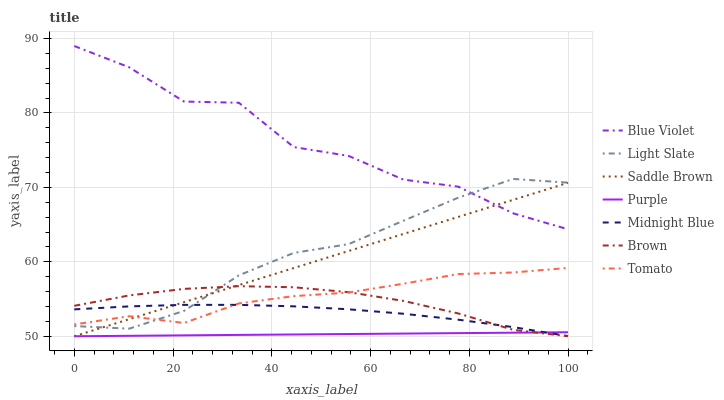Does Purple have the minimum area under the curve?
Answer yes or no. Yes. Does Blue Violet have the maximum area under the curve?
Answer yes or no. Yes. Does Brown have the minimum area under the curve?
Answer yes or no. No. Does Brown have the maximum area under the curve?
Answer yes or no. No. Is Purple the smoothest?
Answer yes or no. Yes. Is Blue Violet the roughest?
Answer yes or no. Yes. Is Brown the smoothest?
Answer yes or no. No. Is Brown the roughest?
Answer yes or no. No. Does Brown have the lowest value?
Answer yes or no. Yes. Does Midnight Blue have the lowest value?
Answer yes or no. No. Does Blue Violet have the highest value?
Answer yes or no. Yes. Does Brown have the highest value?
Answer yes or no. No. Is Brown less than Blue Violet?
Answer yes or no. Yes. Is Blue Violet greater than Purple?
Answer yes or no. Yes. Does Saddle Brown intersect Tomato?
Answer yes or no. Yes. Is Saddle Brown less than Tomato?
Answer yes or no. No. Is Saddle Brown greater than Tomato?
Answer yes or no. No. Does Brown intersect Blue Violet?
Answer yes or no. No. 